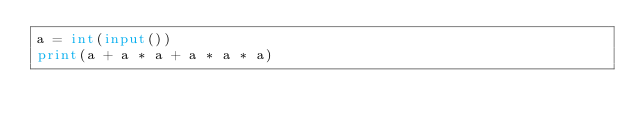<code> <loc_0><loc_0><loc_500><loc_500><_Python_>a = int(input())
print(a + a * a + a * a * a)
</code> 